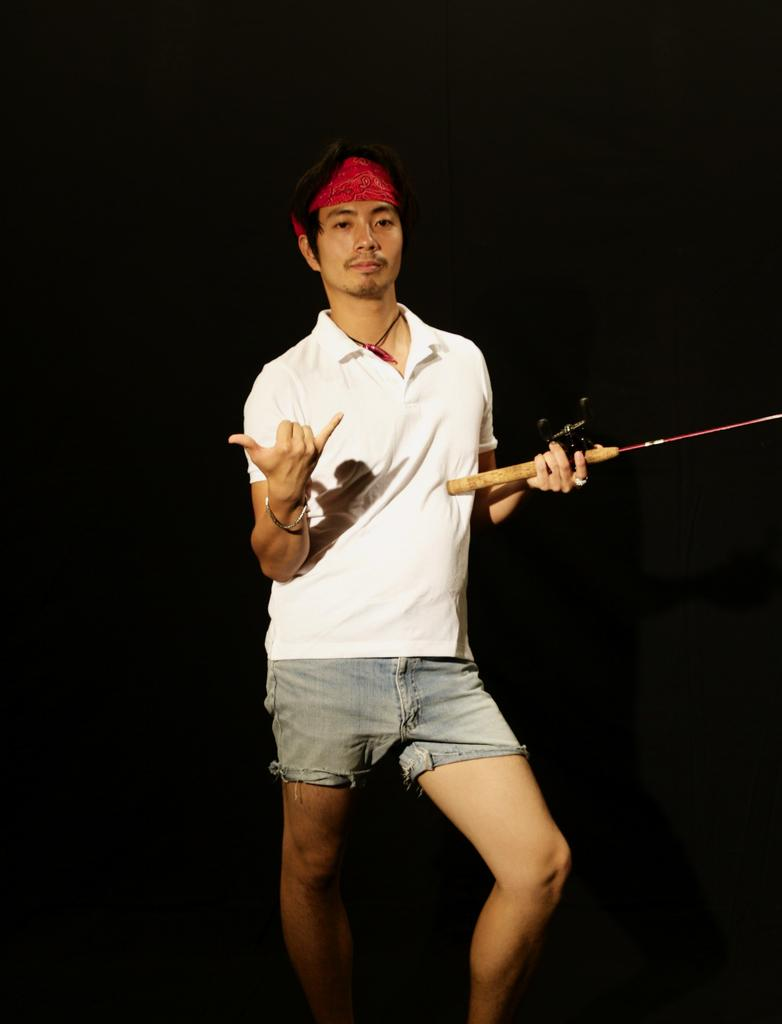What is the main subject of the image? There is a man in the image. What is the man doing in the image? The man is standing and holding a stick with one hand while showing the fingers of another hand. What is the man wearing on his head? The man is wearing a headband. What type of yarn is the man using to create an amusement park in the image? There is no yarn or amusement park present in the image. What color is the crayon the man is using to draw on the stick in the image? There is no crayon or drawing on the stick in the image. 